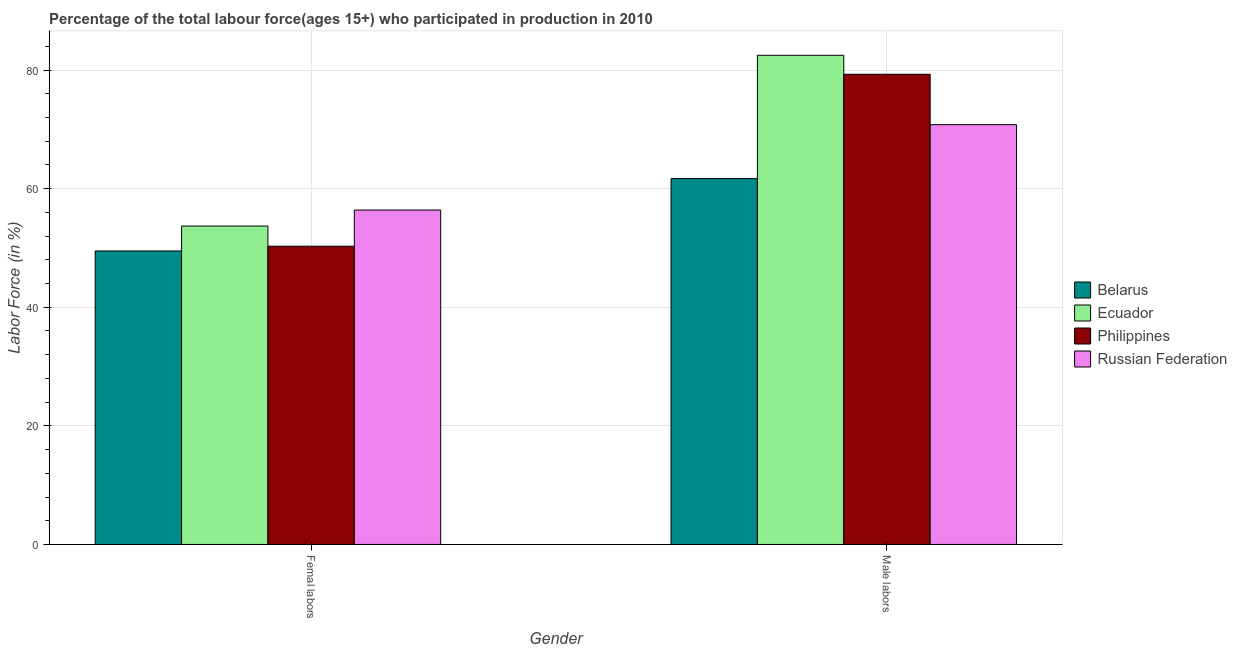How many groups of bars are there?
Give a very brief answer. 2. How many bars are there on the 1st tick from the left?
Ensure brevity in your answer.  4. What is the label of the 2nd group of bars from the left?
Give a very brief answer. Male labors. What is the percentage of female labor force in Ecuador?
Provide a short and direct response. 53.7. Across all countries, what is the maximum percentage of male labour force?
Offer a terse response. 82.5. Across all countries, what is the minimum percentage of female labor force?
Your answer should be compact. 49.5. In which country was the percentage of female labor force maximum?
Give a very brief answer. Russian Federation. In which country was the percentage of female labor force minimum?
Give a very brief answer. Belarus. What is the total percentage of female labor force in the graph?
Provide a short and direct response. 209.9. What is the difference between the percentage of male labour force in Ecuador and that in Russian Federation?
Your response must be concise. 11.7. What is the difference between the percentage of male labour force in Russian Federation and the percentage of female labor force in Ecuador?
Provide a succinct answer. 17.1. What is the average percentage of female labor force per country?
Your answer should be compact. 52.48. What is the difference between the percentage of female labor force and percentage of male labour force in Russian Federation?
Your response must be concise. -14.4. In how many countries, is the percentage of female labor force greater than 8 %?
Offer a very short reply. 4. What is the ratio of the percentage of male labour force in Ecuador to that in Russian Federation?
Offer a terse response. 1.17. In how many countries, is the percentage of female labor force greater than the average percentage of female labor force taken over all countries?
Offer a terse response. 2. What does the 3rd bar from the left in Femal labors represents?
Provide a succinct answer. Philippines. What does the 3rd bar from the right in Male labors represents?
Make the answer very short. Ecuador. How many bars are there?
Ensure brevity in your answer.  8. Are all the bars in the graph horizontal?
Your answer should be compact. No. How many countries are there in the graph?
Ensure brevity in your answer.  4. Are the values on the major ticks of Y-axis written in scientific E-notation?
Your answer should be compact. No. Does the graph contain grids?
Your answer should be compact. Yes. How many legend labels are there?
Give a very brief answer. 4. How are the legend labels stacked?
Make the answer very short. Vertical. What is the title of the graph?
Provide a succinct answer. Percentage of the total labour force(ages 15+) who participated in production in 2010. Does "India" appear as one of the legend labels in the graph?
Make the answer very short. No. What is the label or title of the X-axis?
Provide a short and direct response. Gender. What is the Labor Force (in %) in Belarus in Femal labors?
Keep it short and to the point. 49.5. What is the Labor Force (in %) in Ecuador in Femal labors?
Make the answer very short. 53.7. What is the Labor Force (in %) of Philippines in Femal labors?
Provide a short and direct response. 50.3. What is the Labor Force (in %) of Russian Federation in Femal labors?
Your answer should be compact. 56.4. What is the Labor Force (in %) in Belarus in Male labors?
Give a very brief answer. 61.7. What is the Labor Force (in %) in Ecuador in Male labors?
Your answer should be compact. 82.5. What is the Labor Force (in %) of Philippines in Male labors?
Provide a short and direct response. 79.3. What is the Labor Force (in %) in Russian Federation in Male labors?
Make the answer very short. 70.8. Across all Gender, what is the maximum Labor Force (in %) of Belarus?
Give a very brief answer. 61.7. Across all Gender, what is the maximum Labor Force (in %) in Ecuador?
Your answer should be very brief. 82.5. Across all Gender, what is the maximum Labor Force (in %) of Philippines?
Your answer should be very brief. 79.3. Across all Gender, what is the maximum Labor Force (in %) in Russian Federation?
Your answer should be compact. 70.8. Across all Gender, what is the minimum Labor Force (in %) in Belarus?
Keep it short and to the point. 49.5. Across all Gender, what is the minimum Labor Force (in %) of Ecuador?
Give a very brief answer. 53.7. Across all Gender, what is the minimum Labor Force (in %) in Philippines?
Provide a succinct answer. 50.3. Across all Gender, what is the minimum Labor Force (in %) of Russian Federation?
Keep it short and to the point. 56.4. What is the total Labor Force (in %) of Belarus in the graph?
Ensure brevity in your answer.  111.2. What is the total Labor Force (in %) in Ecuador in the graph?
Ensure brevity in your answer.  136.2. What is the total Labor Force (in %) in Philippines in the graph?
Your answer should be very brief. 129.6. What is the total Labor Force (in %) of Russian Federation in the graph?
Your answer should be compact. 127.2. What is the difference between the Labor Force (in %) in Belarus in Femal labors and that in Male labors?
Your response must be concise. -12.2. What is the difference between the Labor Force (in %) of Ecuador in Femal labors and that in Male labors?
Your answer should be compact. -28.8. What is the difference between the Labor Force (in %) of Philippines in Femal labors and that in Male labors?
Make the answer very short. -29. What is the difference between the Labor Force (in %) in Russian Federation in Femal labors and that in Male labors?
Provide a short and direct response. -14.4. What is the difference between the Labor Force (in %) of Belarus in Femal labors and the Labor Force (in %) of Ecuador in Male labors?
Give a very brief answer. -33. What is the difference between the Labor Force (in %) in Belarus in Femal labors and the Labor Force (in %) in Philippines in Male labors?
Provide a short and direct response. -29.8. What is the difference between the Labor Force (in %) of Belarus in Femal labors and the Labor Force (in %) of Russian Federation in Male labors?
Keep it short and to the point. -21.3. What is the difference between the Labor Force (in %) of Ecuador in Femal labors and the Labor Force (in %) of Philippines in Male labors?
Give a very brief answer. -25.6. What is the difference between the Labor Force (in %) of Ecuador in Femal labors and the Labor Force (in %) of Russian Federation in Male labors?
Your answer should be compact. -17.1. What is the difference between the Labor Force (in %) in Philippines in Femal labors and the Labor Force (in %) in Russian Federation in Male labors?
Ensure brevity in your answer.  -20.5. What is the average Labor Force (in %) in Belarus per Gender?
Provide a succinct answer. 55.6. What is the average Labor Force (in %) in Ecuador per Gender?
Provide a short and direct response. 68.1. What is the average Labor Force (in %) of Philippines per Gender?
Ensure brevity in your answer.  64.8. What is the average Labor Force (in %) of Russian Federation per Gender?
Your answer should be compact. 63.6. What is the difference between the Labor Force (in %) of Belarus and Labor Force (in %) of Ecuador in Femal labors?
Offer a very short reply. -4.2. What is the difference between the Labor Force (in %) of Ecuador and Labor Force (in %) of Russian Federation in Femal labors?
Provide a short and direct response. -2.7. What is the difference between the Labor Force (in %) of Philippines and Labor Force (in %) of Russian Federation in Femal labors?
Offer a very short reply. -6.1. What is the difference between the Labor Force (in %) in Belarus and Labor Force (in %) in Ecuador in Male labors?
Your response must be concise. -20.8. What is the difference between the Labor Force (in %) in Belarus and Labor Force (in %) in Philippines in Male labors?
Provide a succinct answer. -17.6. What is the difference between the Labor Force (in %) in Ecuador and Labor Force (in %) in Philippines in Male labors?
Offer a terse response. 3.2. What is the difference between the Labor Force (in %) in Philippines and Labor Force (in %) in Russian Federation in Male labors?
Keep it short and to the point. 8.5. What is the ratio of the Labor Force (in %) of Belarus in Femal labors to that in Male labors?
Your answer should be very brief. 0.8. What is the ratio of the Labor Force (in %) in Ecuador in Femal labors to that in Male labors?
Ensure brevity in your answer.  0.65. What is the ratio of the Labor Force (in %) in Philippines in Femal labors to that in Male labors?
Your answer should be very brief. 0.63. What is the ratio of the Labor Force (in %) in Russian Federation in Femal labors to that in Male labors?
Offer a very short reply. 0.8. What is the difference between the highest and the second highest Labor Force (in %) in Belarus?
Provide a short and direct response. 12.2. What is the difference between the highest and the second highest Labor Force (in %) of Ecuador?
Ensure brevity in your answer.  28.8. What is the difference between the highest and the second highest Labor Force (in %) of Philippines?
Offer a very short reply. 29. What is the difference between the highest and the lowest Labor Force (in %) of Ecuador?
Offer a terse response. 28.8. What is the difference between the highest and the lowest Labor Force (in %) of Philippines?
Provide a succinct answer. 29. What is the difference between the highest and the lowest Labor Force (in %) in Russian Federation?
Offer a very short reply. 14.4. 